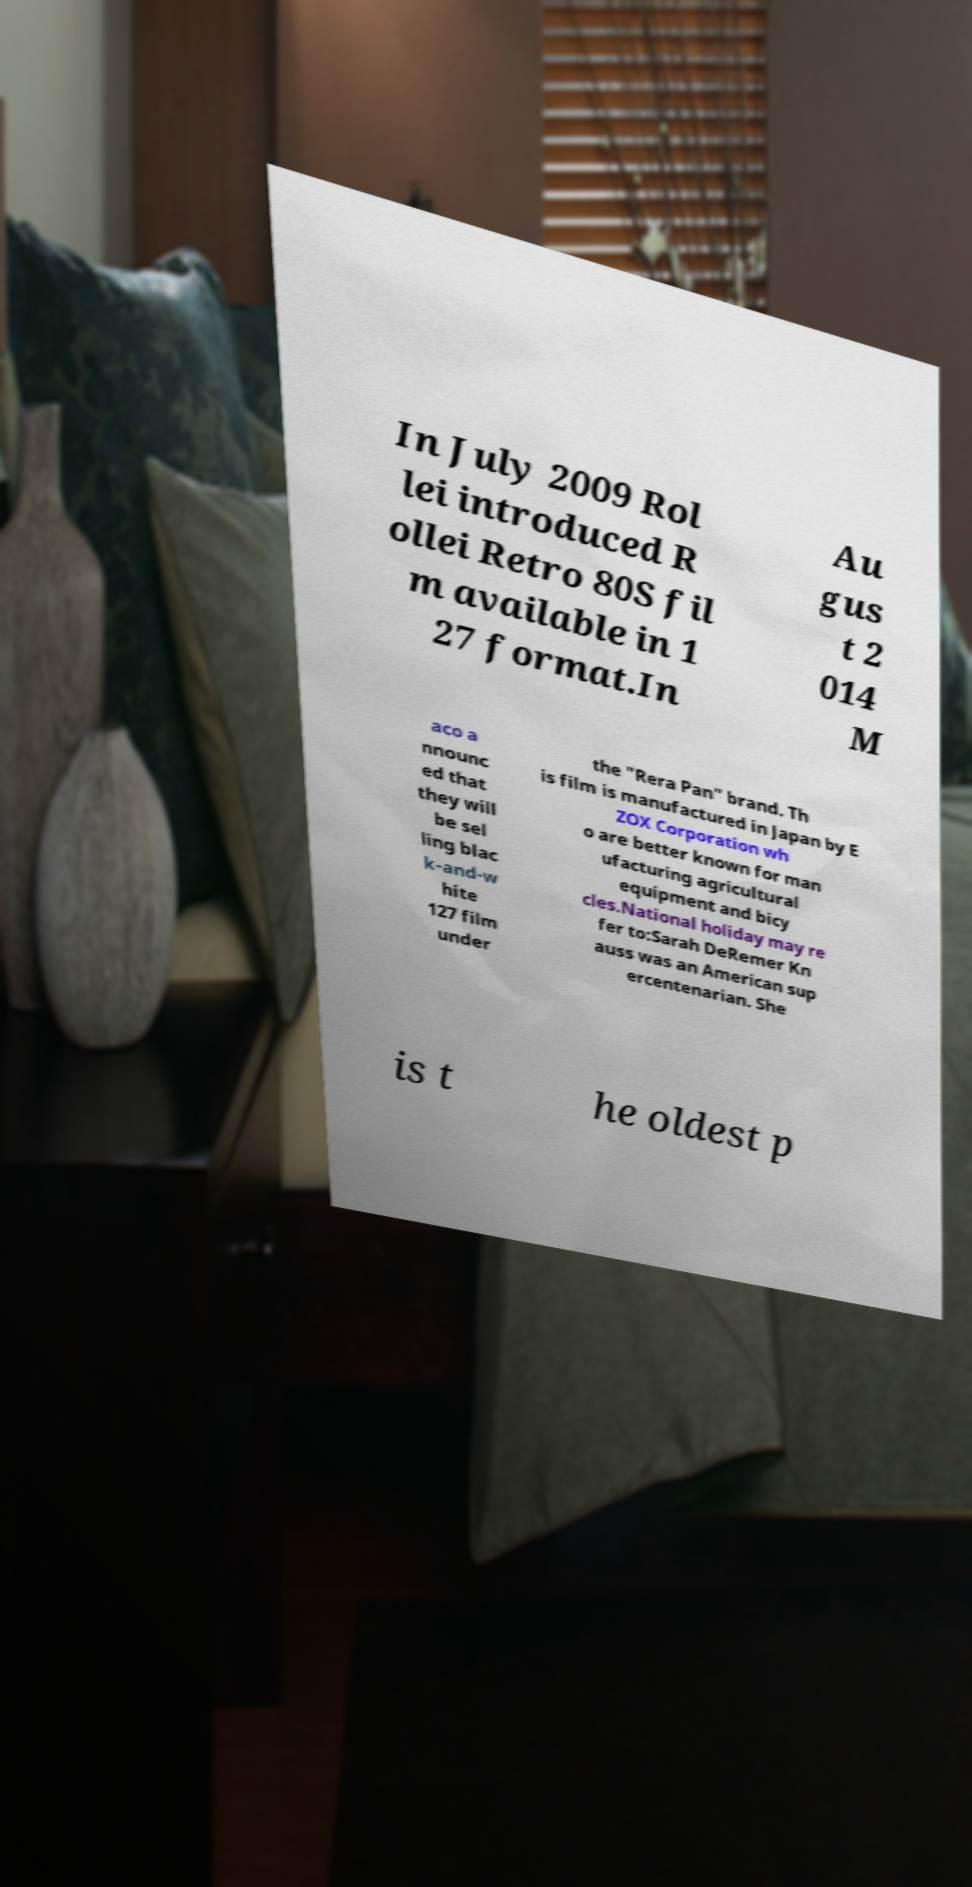Please identify and transcribe the text found in this image. In July 2009 Rol lei introduced R ollei Retro 80S fil m available in 1 27 format.In Au gus t 2 014 M aco a nnounc ed that they will be sel ling blac k-and-w hite 127 film under the "Rera Pan" brand. Th is film is manufactured in Japan by E ZOX Corporation wh o are better known for man ufacturing agricultural equipment and bicy cles.National holiday may re fer to:Sarah DeRemer Kn auss was an American sup ercentenarian. She is t he oldest p 